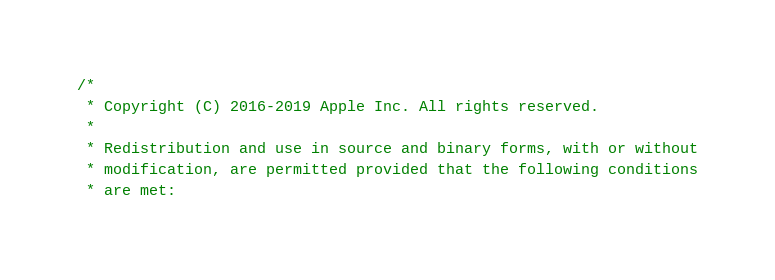Convert code to text. <code><loc_0><loc_0><loc_500><loc_500><_C_>/*
 * Copyright (C) 2016-2019 Apple Inc. All rights reserved.
 *
 * Redistribution and use in source and binary forms, with or without
 * modification, are permitted provided that the following conditions
 * are met:</code> 